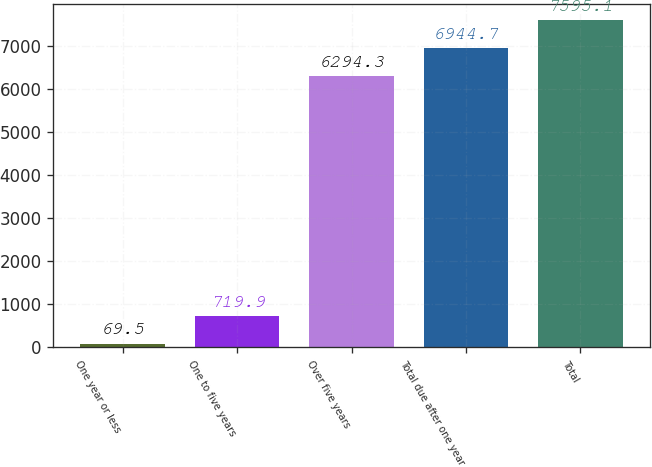Convert chart to OTSL. <chart><loc_0><loc_0><loc_500><loc_500><bar_chart><fcel>One year or less<fcel>One to five years<fcel>Over five years<fcel>Total due after one year<fcel>Total<nl><fcel>69.5<fcel>719.9<fcel>6294.3<fcel>6944.7<fcel>7595.1<nl></chart> 